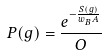<formula> <loc_0><loc_0><loc_500><loc_500>P ( g ) = \frac { e ^ { - \frac { S ( g ) } { w _ { B } A } } } { O }</formula> 